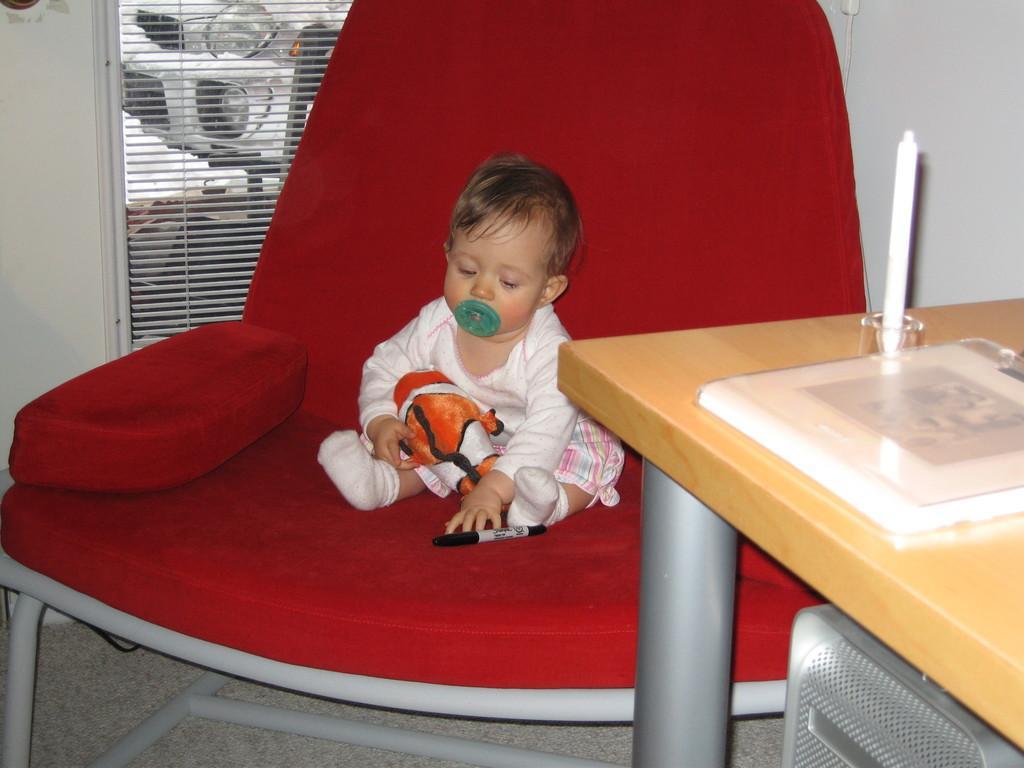Describe this image in one or two sentences. There is a kid with cap in his mouth and a pen near to his legs,sitting on the chair. On the right there is a candle on the table and a box on it. In the background there is a wall and window, behind the window there is a vehicle. 